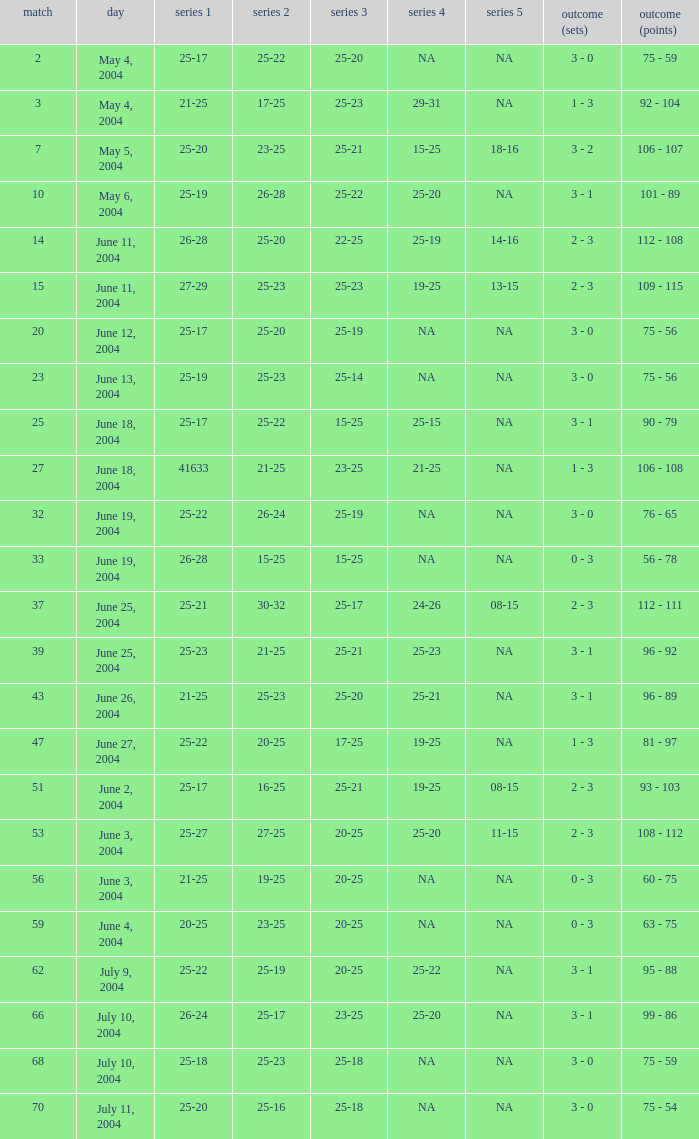What is the set 5 for the game with a set 2 of 21-25 and a set 1 of 41633? NA. 